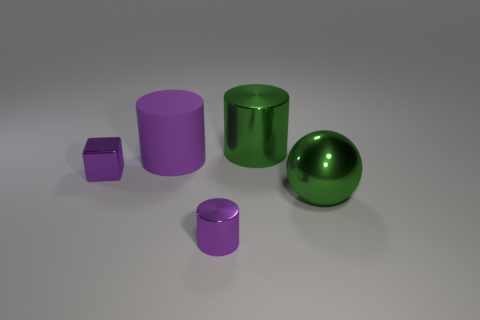Are there any other things that are the same shape as the large purple matte thing?
Provide a short and direct response. Yes. What number of rubber things are small balls or green cylinders?
Keep it short and to the point. 0. Is the number of green shiny balls that are behind the shiny sphere less than the number of tiny purple blocks?
Offer a very short reply. Yes. There is a shiny thing that is left of the small purple shiny object that is right of the tiny metal thing that is behind the small metal cylinder; what shape is it?
Your answer should be compact. Cube. Is the color of the large rubber cylinder the same as the tiny metal cube?
Provide a short and direct response. Yes. Are there more yellow metallic cylinders than large objects?
Provide a short and direct response. No. What number of other objects are there of the same material as the green ball?
Your answer should be very brief. 3. What number of objects are either tiny cubes or tiny shiny things in front of the sphere?
Keep it short and to the point. 2. Are there fewer small rubber spheres than tiny purple shiny blocks?
Your answer should be very brief. Yes. There is a large cylinder to the right of the metallic cylinder in front of the green metal cylinder behind the small shiny block; what color is it?
Ensure brevity in your answer.  Green. 